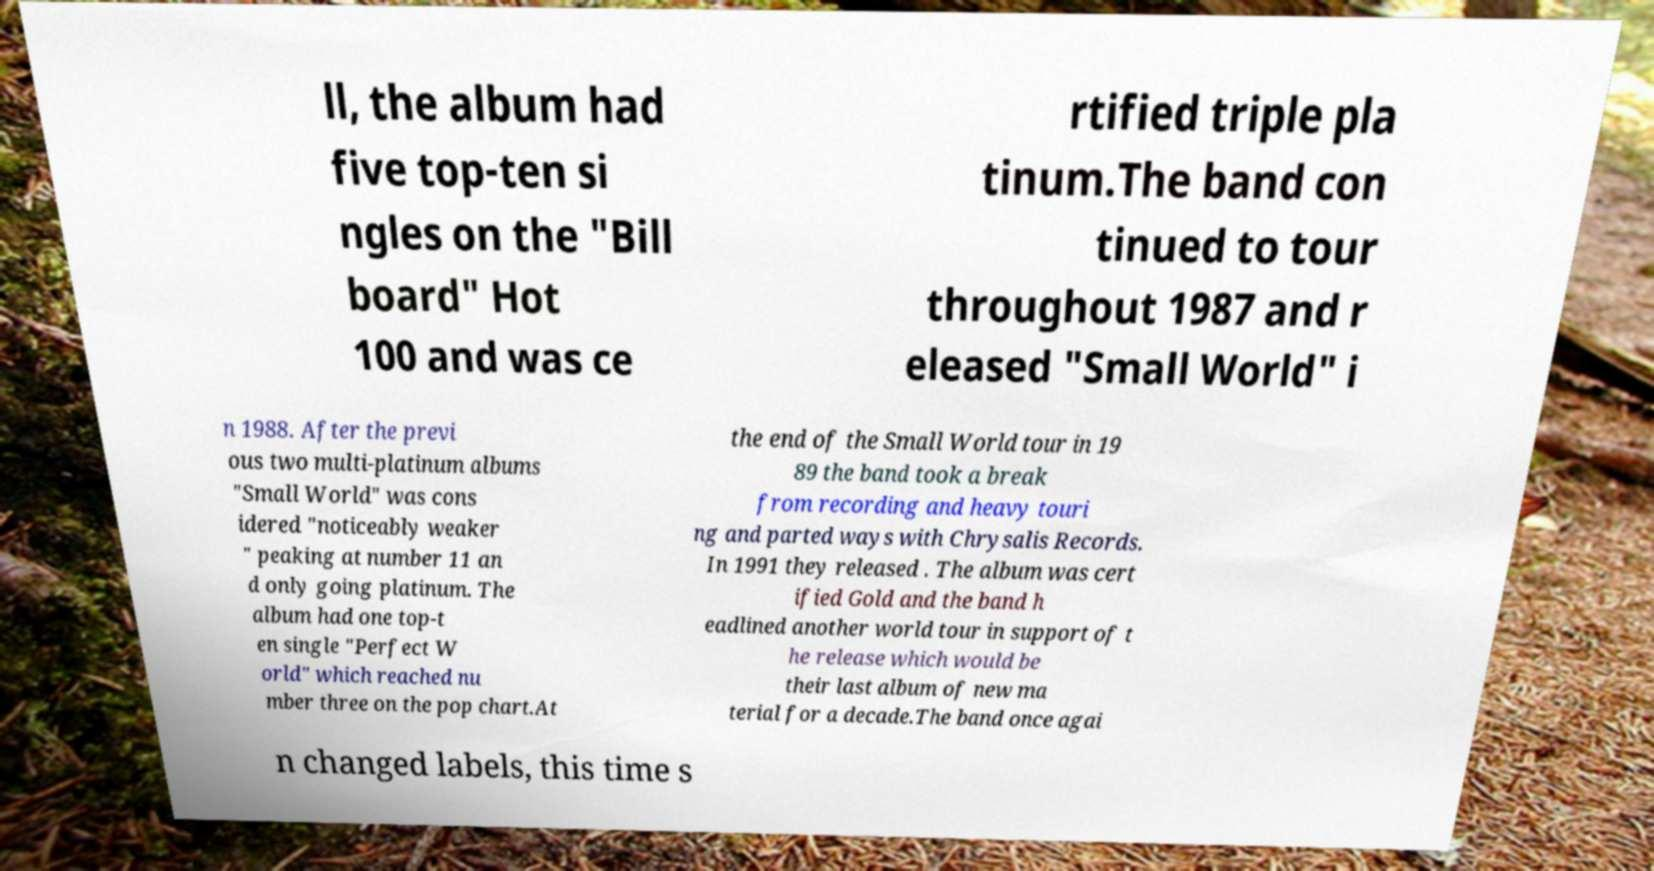Can you accurately transcribe the text from the provided image for me? ll, the album had five top-ten si ngles on the "Bill board" Hot 100 and was ce rtified triple pla tinum.The band con tinued to tour throughout 1987 and r eleased "Small World" i n 1988. After the previ ous two multi-platinum albums "Small World" was cons idered "noticeably weaker " peaking at number 11 an d only going platinum. The album had one top-t en single "Perfect W orld" which reached nu mber three on the pop chart.At the end of the Small World tour in 19 89 the band took a break from recording and heavy touri ng and parted ways with Chrysalis Records. In 1991 they released . The album was cert ified Gold and the band h eadlined another world tour in support of t he release which would be their last album of new ma terial for a decade.The band once agai n changed labels, this time s 